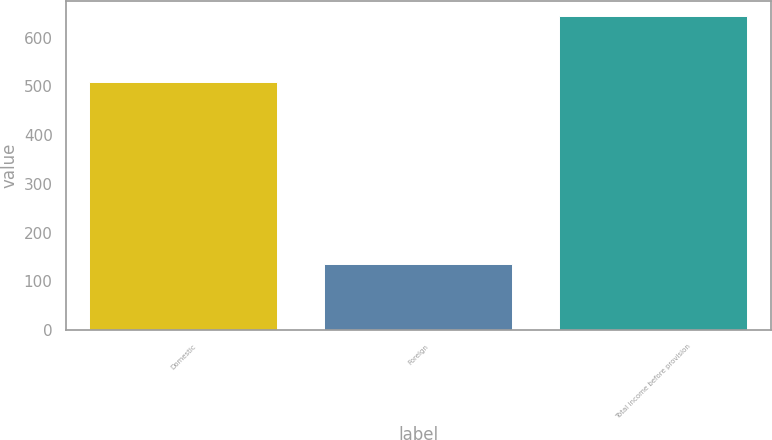<chart> <loc_0><loc_0><loc_500><loc_500><bar_chart><fcel>Domestic<fcel>Foreign<fcel>Total income before provision<nl><fcel>508.6<fcel>134.7<fcel>643.3<nl></chart> 